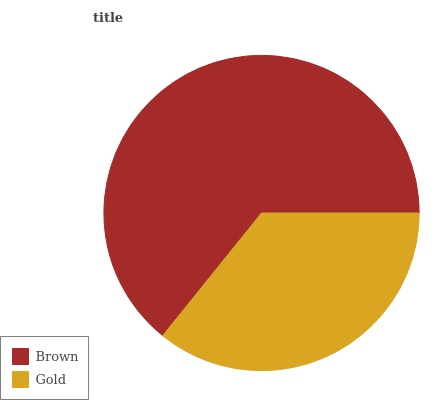Is Gold the minimum?
Answer yes or no. Yes. Is Brown the maximum?
Answer yes or no. Yes. Is Gold the maximum?
Answer yes or no. No. Is Brown greater than Gold?
Answer yes or no. Yes. Is Gold less than Brown?
Answer yes or no. Yes. Is Gold greater than Brown?
Answer yes or no. No. Is Brown less than Gold?
Answer yes or no. No. Is Brown the high median?
Answer yes or no. Yes. Is Gold the low median?
Answer yes or no. Yes. Is Gold the high median?
Answer yes or no. No. Is Brown the low median?
Answer yes or no. No. 